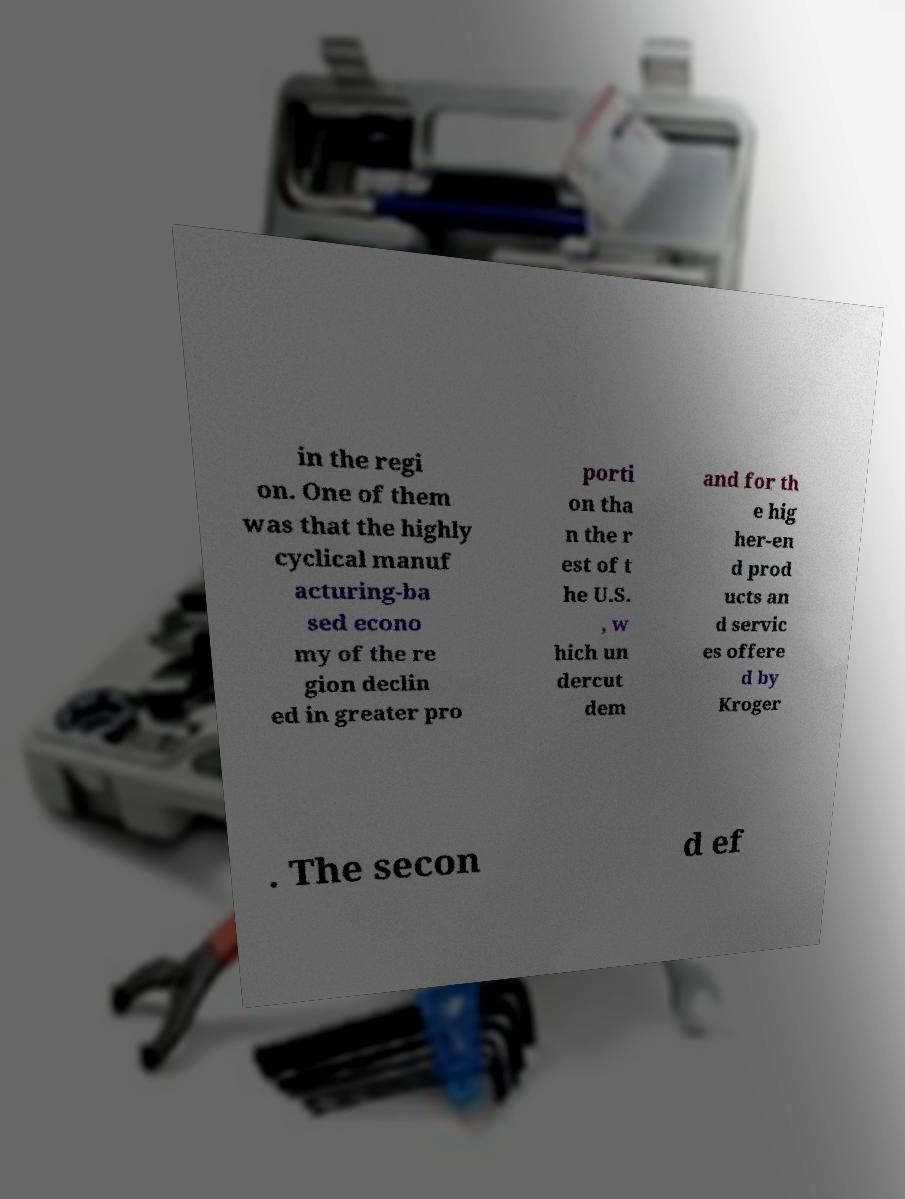Can you read and provide the text displayed in the image?This photo seems to have some interesting text. Can you extract and type it out for me? in the regi on. One of them was that the highly cyclical manuf acturing-ba sed econo my of the re gion declin ed in greater pro porti on tha n the r est of t he U.S. , w hich un dercut dem and for th e hig her-en d prod ucts an d servic es offere d by Kroger . The secon d ef 